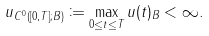Convert formula to latex. <formula><loc_0><loc_0><loc_500><loc_500>\| u \| _ { C ^ { 0 } ( [ 0 , T ] ; B ) } \coloneqq \max _ { 0 \leq t \leq T } \| u ( t ) \| _ { B } < \infty .</formula> 